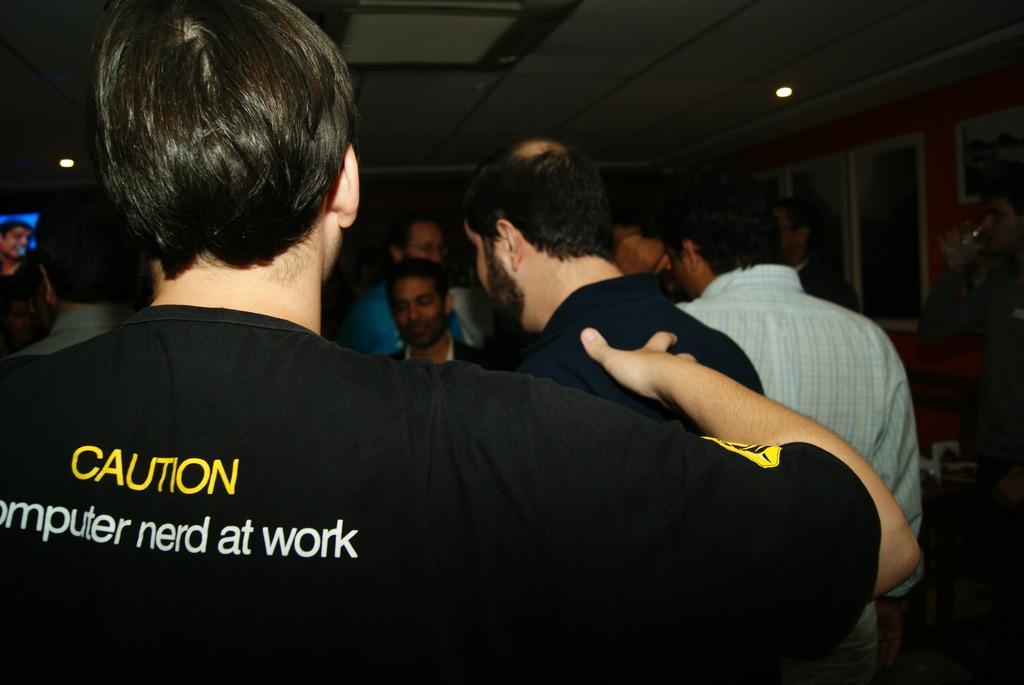Could you give a brief overview of what you see in this image? In the center of the image we can see a few people are standing and they are in different costumes. And the front person is in a black t shirt. On the t shirt, we can see some text. In the background there is a wall, window, frame, light, one monitor and a few other objects. 